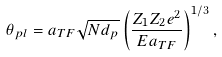<formula> <loc_0><loc_0><loc_500><loc_500>\theta _ { p l } = a _ { T F } \sqrt { N d _ { p } } \left ( \frac { Z _ { 1 } Z _ { 2 } e ^ { 2 } } { E a _ { T F } } \right ) ^ { 1 / 3 } ,</formula> 